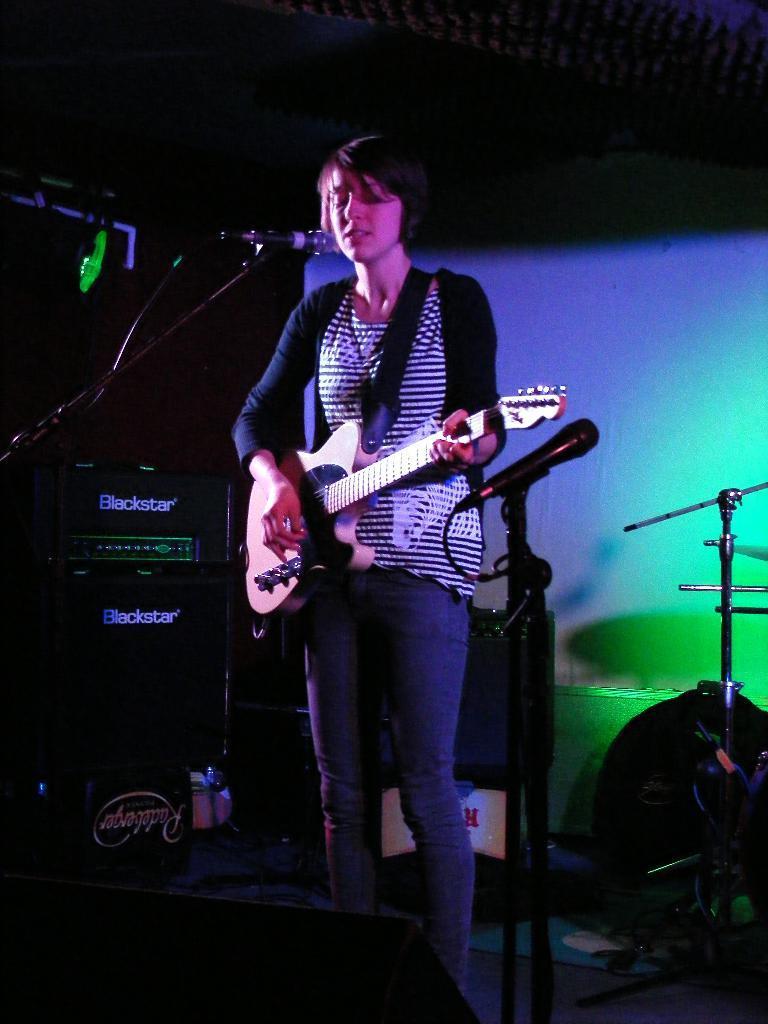In one or two sentences, can you explain what this image depicts? In this picture one woman is standing in blue jeans and black shirt where she is playing a guitar in front of the microphone and behind her there are speakers, one bag and a big curtain. 